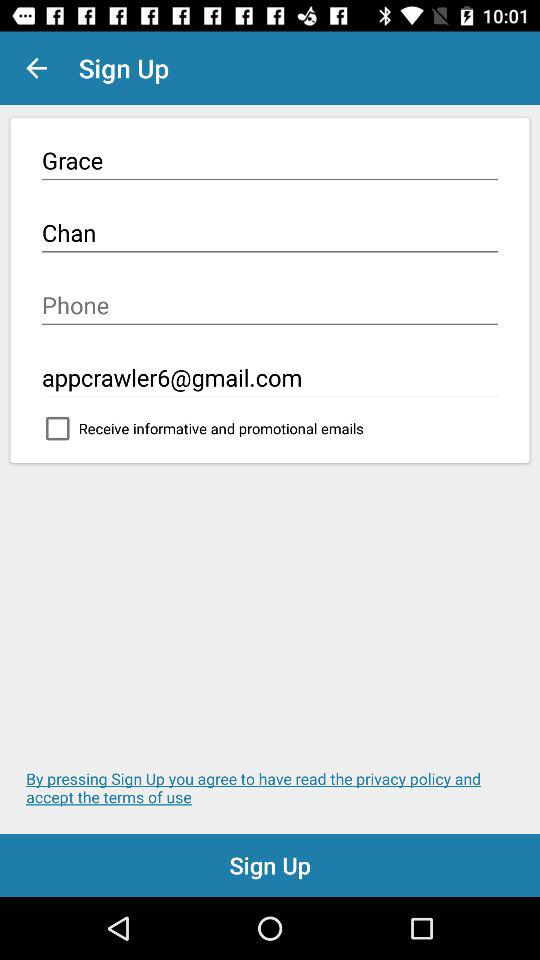What is the last name used to sign up? The last name used to sign up is Chan. 